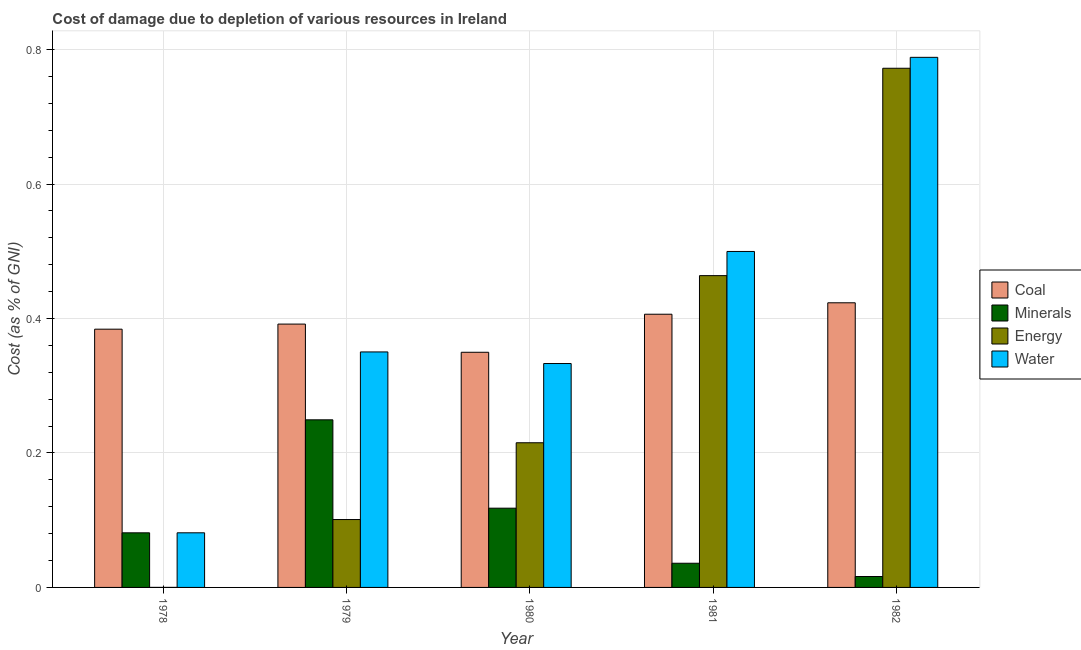How many different coloured bars are there?
Your response must be concise. 4. Are the number of bars per tick equal to the number of legend labels?
Keep it short and to the point. Yes. Are the number of bars on each tick of the X-axis equal?
Offer a terse response. Yes. How many bars are there on the 1st tick from the left?
Ensure brevity in your answer.  4. How many bars are there on the 2nd tick from the right?
Offer a terse response. 4. What is the label of the 4th group of bars from the left?
Provide a succinct answer. 1981. What is the cost of damage due to depletion of coal in 1982?
Your answer should be very brief. 0.42. Across all years, what is the maximum cost of damage due to depletion of water?
Make the answer very short. 0.79. Across all years, what is the minimum cost of damage due to depletion of coal?
Your response must be concise. 0.35. In which year was the cost of damage due to depletion of water maximum?
Provide a succinct answer. 1982. In which year was the cost of damage due to depletion of energy minimum?
Your answer should be compact. 1978. What is the total cost of damage due to depletion of water in the graph?
Offer a terse response. 2.05. What is the difference between the cost of damage due to depletion of coal in 1981 and that in 1982?
Ensure brevity in your answer.  -0.02. What is the difference between the cost of damage due to depletion of minerals in 1982 and the cost of damage due to depletion of coal in 1980?
Your answer should be very brief. -0.1. What is the average cost of damage due to depletion of minerals per year?
Make the answer very short. 0.1. In the year 1981, what is the difference between the cost of damage due to depletion of minerals and cost of damage due to depletion of coal?
Offer a very short reply. 0. In how many years, is the cost of damage due to depletion of minerals greater than 0.32 %?
Make the answer very short. 0. What is the ratio of the cost of damage due to depletion of energy in 1980 to that in 1981?
Offer a terse response. 0.46. What is the difference between the highest and the second highest cost of damage due to depletion of minerals?
Your answer should be very brief. 0.13. What is the difference between the highest and the lowest cost of damage due to depletion of coal?
Offer a terse response. 0.07. In how many years, is the cost of damage due to depletion of minerals greater than the average cost of damage due to depletion of minerals taken over all years?
Provide a succinct answer. 2. What does the 2nd bar from the left in 1979 represents?
Make the answer very short. Minerals. What does the 1st bar from the right in 1981 represents?
Provide a succinct answer. Water. Are all the bars in the graph horizontal?
Your answer should be very brief. No. What is the difference between two consecutive major ticks on the Y-axis?
Offer a terse response. 0.2. Where does the legend appear in the graph?
Keep it short and to the point. Center right. How many legend labels are there?
Provide a succinct answer. 4. What is the title of the graph?
Provide a short and direct response. Cost of damage due to depletion of various resources in Ireland . What is the label or title of the X-axis?
Your answer should be very brief. Year. What is the label or title of the Y-axis?
Your response must be concise. Cost (as % of GNI). What is the Cost (as % of GNI) in Coal in 1978?
Your answer should be very brief. 0.38. What is the Cost (as % of GNI) of Minerals in 1978?
Your answer should be very brief. 0.08. What is the Cost (as % of GNI) of Energy in 1978?
Offer a terse response. 3.38604174226955e-5. What is the Cost (as % of GNI) in Water in 1978?
Provide a short and direct response. 0.08. What is the Cost (as % of GNI) in Coal in 1979?
Make the answer very short. 0.39. What is the Cost (as % of GNI) in Minerals in 1979?
Keep it short and to the point. 0.25. What is the Cost (as % of GNI) of Energy in 1979?
Give a very brief answer. 0.1. What is the Cost (as % of GNI) of Water in 1979?
Provide a short and direct response. 0.35. What is the Cost (as % of GNI) in Coal in 1980?
Provide a short and direct response. 0.35. What is the Cost (as % of GNI) of Minerals in 1980?
Give a very brief answer. 0.12. What is the Cost (as % of GNI) in Energy in 1980?
Offer a very short reply. 0.22. What is the Cost (as % of GNI) in Water in 1980?
Offer a very short reply. 0.33. What is the Cost (as % of GNI) in Coal in 1981?
Your response must be concise. 0.41. What is the Cost (as % of GNI) in Minerals in 1981?
Ensure brevity in your answer.  0.04. What is the Cost (as % of GNI) in Energy in 1981?
Your answer should be very brief. 0.46. What is the Cost (as % of GNI) in Water in 1981?
Offer a very short reply. 0.5. What is the Cost (as % of GNI) in Coal in 1982?
Provide a short and direct response. 0.42. What is the Cost (as % of GNI) of Minerals in 1982?
Your response must be concise. 0.02. What is the Cost (as % of GNI) in Energy in 1982?
Your response must be concise. 0.77. What is the Cost (as % of GNI) in Water in 1982?
Your response must be concise. 0.79. Across all years, what is the maximum Cost (as % of GNI) of Coal?
Your response must be concise. 0.42. Across all years, what is the maximum Cost (as % of GNI) in Minerals?
Keep it short and to the point. 0.25. Across all years, what is the maximum Cost (as % of GNI) in Energy?
Provide a succinct answer. 0.77. Across all years, what is the maximum Cost (as % of GNI) of Water?
Your response must be concise. 0.79. Across all years, what is the minimum Cost (as % of GNI) in Coal?
Make the answer very short. 0.35. Across all years, what is the minimum Cost (as % of GNI) of Minerals?
Ensure brevity in your answer.  0.02. Across all years, what is the minimum Cost (as % of GNI) in Energy?
Provide a succinct answer. 3.38604174226955e-5. Across all years, what is the minimum Cost (as % of GNI) of Water?
Keep it short and to the point. 0.08. What is the total Cost (as % of GNI) in Coal in the graph?
Make the answer very short. 1.96. What is the total Cost (as % of GNI) in Minerals in the graph?
Provide a short and direct response. 0.5. What is the total Cost (as % of GNI) in Energy in the graph?
Keep it short and to the point. 1.55. What is the total Cost (as % of GNI) in Water in the graph?
Your answer should be very brief. 2.05. What is the difference between the Cost (as % of GNI) of Coal in 1978 and that in 1979?
Offer a very short reply. -0.01. What is the difference between the Cost (as % of GNI) of Minerals in 1978 and that in 1979?
Provide a succinct answer. -0.17. What is the difference between the Cost (as % of GNI) of Energy in 1978 and that in 1979?
Your answer should be very brief. -0.1. What is the difference between the Cost (as % of GNI) in Water in 1978 and that in 1979?
Your response must be concise. -0.27. What is the difference between the Cost (as % of GNI) in Coal in 1978 and that in 1980?
Your answer should be very brief. 0.03. What is the difference between the Cost (as % of GNI) in Minerals in 1978 and that in 1980?
Provide a succinct answer. -0.04. What is the difference between the Cost (as % of GNI) in Energy in 1978 and that in 1980?
Your answer should be very brief. -0.22. What is the difference between the Cost (as % of GNI) in Water in 1978 and that in 1980?
Provide a succinct answer. -0.25. What is the difference between the Cost (as % of GNI) of Coal in 1978 and that in 1981?
Your response must be concise. -0.02. What is the difference between the Cost (as % of GNI) in Minerals in 1978 and that in 1981?
Provide a succinct answer. 0.05. What is the difference between the Cost (as % of GNI) in Energy in 1978 and that in 1981?
Your response must be concise. -0.46. What is the difference between the Cost (as % of GNI) in Water in 1978 and that in 1981?
Your answer should be compact. -0.42. What is the difference between the Cost (as % of GNI) of Coal in 1978 and that in 1982?
Your response must be concise. -0.04. What is the difference between the Cost (as % of GNI) in Minerals in 1978 and that in 1982?
Your answer should be very brief. 0.07. What is the difference between the Cost (as % of GNI) of Energy in 1978 and that in 1982?
Provide a succinct answer. -0.77. What is the difference between the Cost (as % of GNI) in Water in 1978 and that in 1982?
Ensure brevity in your answer.  -0.71. What is the difference between the Cost (as % of GNI) of Coal in 1979 and that in 1980?
Give a very brief answer. 0.04. What is the difference between the Cost (as % of GNI) in Minerals in 1979 and that in 1980?
Make the answer very short. 0.13. What is the difference between the Cost (as % of GNI) of Energy in 1979 and that in 1980?
Ensure brevity in your answer.  -0.11. What is the difference between the Cost (as % of GNI) of Water in 1979 and that in 1980?
Your response must be concise. 0.02. What is the difference between the Cost (as % of GNI) of Coal in 1979 and that in 1981?
Your answer should be compact. -0.01. What is the difference between the Cost (as % of GNI) in Minerals in 1979 and that in 1981?
Offer a terse response. 0.21. What is the difference between the Cost (as % of GNI) of Energy in 1979 and that in 1981?
Provide a succinct answer. -0.36. What is the difference between the Cost (as % of GNI) in Water in 1979 and that in 1981?
Provide a succinct answer. -0.15. What is the difference between the Cost (as % of GNI) in Coal in 1979 and that in 1982?
Your answer should be compact. -0.03. What is the difference between the Cost (as % of GNI) of Minerals in 1979 and that in 1982?
Your answer should be very brief. 0.23. What is the difference between the Cost (as % of GNI) in Energy in 1979 and that in 1982?
Make the answer very short. -0.67. What is the difference between the Cost (as % of GNI) in Water in 1979 and that in 1982?
Make the answer very short. -0.44. What is the difference between the Cost (as % of GNI) in Coal in 1980 and that in 1981?
Your answer should be compact. -0.06. What is the difference between the Cost (as % of GNI) in Minerals in 1980 and that in 1981?
Ensure brevity in your answer.  0.08. What is the difference between the Cost (as % of GNI) in Energy in 1980 and that in 1981?
Offer a very short reply. -0.25. What is the difference between the Cost (as % of GNI) of Coal in 1980 and that in 1982?
Offer a very short reply. -0.07. What is the difference between the Cost (as % of GNI) in Minerals in 1980 and that in 1982?
Keep it short and to the point. 0.1. What is the difference between the Cost (as % of GNI) in Energy in 1980 and that in 1982?
Ensure brevity in your answer.  -0.56. What is the difference between the Cost (as % of GNI) of Water in 1980 and that in 1982?
Your response must be concise. -0.46. What is the difference between the Cost (as % of GNI) of Coal in 1981 and that in 1982?
Keep it short and to the point. -0.02. What is the difference between the Cost (as % of GNI) in Minerals in 1981 and that in 1982?
Your answer should be compact. 0.02. What is the difference between the Cost (as % of GNI) of Energy in 1981 and that in 1982?
Give a very brief answer. -0.31. What is the difference between the Cost (as % of GNI) of Water in 1981 and that in 1982?
Your answer should be very brief. -0.29. What is the difference between the Cost (as % of GNI) in Coal in 1978 and the Cost (as % of GNI) in Minerals in 1979?
Your response must be concise. 0.13. What is the difference between the Cost (as % of GNI) in Coal in 1978 and the Cost (as % of GNI) in Energy in 1979?
Your answer should be compact. 0.28. What is the difference between the Cost (as % of GNI) of Coal in 1978 and the Cost (as % of GNI) of Water in 1979?
Offer a terse response. 0.03. What is the difference between the Cost (as % of GNI) of Minerals in 1978 and the Cost (as % of GNI) of Energy in 1979?
Provide a succinct answer. -0.02. What is the difference between the Cost (as % of GNI) in Minerals in 1978 and the Cost (as % of GNI) in Water in 1979?
Make the answer very short. -0.27. What is the difference between the Cost (as % of GNI) of Energy in 1978 and the Cost (as % of GNI) of Water in 1979?
Provide a short and direct response. -0.35. What is the difference between the Cost (as % of GNI) of Coal in 1978 and the Cost (as % of GNI) of Minerals in 1980?
Provide a succinct answer. 0.27. What is the difference between the Cost (as % of GNI) in Coal in 1978 and the Cost (as % of GNI) in Energy in 1980?
Make the answer very short. 0.17. What is the difference between the Cost (as % of GNI) in Coal in 1978 and the Cost (as % of GNI) in Water in 1980?
Make the answer very short. 0.05. What is the difference between the Cost (as % of GNI) in Minerals in 1978 and the Cost (as % of GNI) in Energy in 1980?
Offer a terse response. -0.13. What is the difference between the Cost (as % of GNI) in Minerals in 1978 and the Cost (as % of GNI) in Water in 1980?
Keep it short and to the point. -0.25. What is the difference between the Cost (as % of GNI) of Energy in 1978 and the Cost (as % of GNI) of Water in 1980?
Your response must be concise. -0.33. What is the difference between the Cost (as % of GNI) of Coal in 1978 and the Cost (as % of GNI) of Minerals in 1981?
Offer a terse response. 0.35. What is the difference between the Cost (as % of GNI) in Coal in 1978 and the Cost (as % of GNI) in Energy in 1981?
Your answer should be very brief. -0.08. What is the difference between the Cost (as % of GNI) of Coal in 1978 and the Cost (as % of GNI) of Water in 1981?
Provide a short and direct response. -0.12. What is the difference between the Cost (as % of GNI) of Minerals in 1978 and the Cost (as % of GNI) of Energy in 1981?
Your answer should be very brief. -0.38. What is the difference between the Cost (as % of GNI) in Minerals in 1978 and the Cost (as % of GNI) in Water in 1981?
Your answer should be compact. -0.42. What is the difference between the Cost (as % of GNI) of Energy in 1978 and the Cost (as % of GNI) of Water in 1981?
Ensure brevity in your answer.  -0.5. What is the difference between the Cost (as % of GNI) of Coal in 1978 and the Cost (as % of GNI) of Minerals in 1982?
Keep it short and to the point. 0.37. What is the difference between the Cost (as % of GNI) in Coal in 1978 and the Cost (as % of GNI) in Energy in 1982?
Offer a very short reply. -0.39. What is the difference between the Cost (as % of GNI) of Coal in 1978 and the Cost (as % of GNI) of Water in 1982?
Make the answer very short. -0.4. What is the difference between the Cost (as % of GNI) of Minerals in 1978 and the Cost (as % of GNI) of Energy in 1982?
Provide a short and direct response. -0.69. What is the difference between the Cost (as % of GNI) in Minerals in 1978 and the Cost (as % of GNI) in Water in 1982?
Give a very brief answer. -0.71. What is the difference between the Cost (as % of GNI) of Energy in 1978 and the Cost (as % of GNI) of Water in 1982?
Give a very brief answer. -0.79. What is the difference between the Cost (as % of GNI) in Coal in 1979 and the Cost (as % of GNI) in Minerals in 1980?
Your answer should be compact. 0.27. What is the difference between the Cost (as % of GNI) in Coal in 1979 and the Cost (as % of GNI) in Energy in 1980?
Provide a short and direct response. 0.18. What is the difference between the Cost (as % of GNI) of Coal in 1979 and the Cost (as % of GNI) of Water in 1980?
Provide a succinct answer. 0.06. What is the difference between the Cost (as % of GNI) of Minerals in 1979 and the Cost (as % of GNI) of Energy in 1980?
Your answer should be compact. 0.03. What is the difference between the Cost (as % of GNI) of Minerals in 1979 and the Cost (as % of GNI) of Water in 1980?
Your answer should be very brief. -0.08. What is the difference between the Cost (as % of GNI) in Energy in 1979 and the Cost (as % of GNI) in Water in 1980?
Give a very brief answer. -0.23. What is the difference between the Cost (as % of GNI) of Coal in 1979 and the Cost (as % of GNI) of Minerals in 1981?
Provide a short and direct response. 0.36. What is the difference between the Cost (as % of GNI) in Coal in 1979 and the Cost (as % of GNI) in Energy in 1981?
Keep it short and to the point. -0.07. What is the difference between the Cost (as % of GNI) of Coal in 1979 and the Cost (as % of GNI) of Water in 1981?
Make the answer very short. -0.11. What is the difference between the Cost (as % of GNI) of Minerals in 1979 and the Cost (as % of GNI) of Energy in 1981?
Offer a terse response. -0.21. What is the difference between the Cost (as % of GNI) in Minerals in 1979 and the Cost (as % of GNI) in Water in 1981?
Make the answer very short. -0.25. What is the difference between the Cost (as % of GNI) in Energy in 1979 and the Cost (as % of GNI) in Water in 1981?
Offer a terse response. -0.4. What is the difference between the Cost (as % of GNI) of Coal in 1979 and the Cost (as % of GNI) of Minerals in 1982?
Keep it short and to the point. 0.38. What is the difference between the Cost (as % of GNI) in Coal in 1979 and the Cost (as % of GNI) in Energy in 1982?
Make the answer very short. -0.38. What is the difference between the Cost (as % of GNI) of Coal in 1979 and the Cost (as % of GNI) of Water in 1982?
Your answer should be very brief. -0.4. What is the difference between the Cost (as % of GNI) of Minerals in 1979 and the Cost (as % of GNI) of Energy in 1982?
Offer a terse response. -0.52. What is the difference between the Cost (as % of GNI) in Minerals in 1979 and the Cost (as % of GNI) in Water in 1982?
Offer a very short reply. -0.54. What is the difference between the Cost (as % of GNI) in Energy in 1979 and the Cost (as % of GNI) in Water in 1982?
Your response must be concise. -0.69. What is the difference between the Cost (as % of GNI) in Coal in 1980 and the Cost (as % of GNI) in Minerals in 1981?
Give a very brief answer. 0.31. What is the difference between the Cost (as % of GNI) of Coal in 1980 and the Cost (as % of GNI) of Energy in 1981?
Keep it short and to the point. -0.11. What is the difference between the Cost (as % of GNI) of Minerals in 1980 and the Cost (as % of GNI) of Energy in 1981?
Provide a short and direct response. -0.35. What is the difference between the Cost (as % of GNI) of Minerals in 1980 and the Cost (as % of GNI) of Water in 1981?
Give a very brief answer. -0.38. What is the difference between the Cost (as % of GNI) in Energy in 1980 and the Cost (as % of GNI) in Water in 1981?
Give a very brief answer. -0.28. What is the difference between the Cost (as % of GNI) in Coal in 1980 and the Cost (as % of GNI) in Minerals in 1982?
Provide a short and direct response. 0.33. What is the difference between the Cost (as % of GNI) in Coal in 1980 and the Cost (as % of GNI) in Energy in 1982?
Make the answer very short. -0.42. What is the difference between the Cost (as % of GNI) of Coal in 1980 and the Cost (as % of GNI) of Water in 1982?
Your response must be concise. -0.44. What is the difference between the Cost (as % of GNI) of Minerals in 1980 and the Cost (as % of GNI) of Energy in 1982?
Your answer should be compact. -0.65. What is the difference between the Cost (as % of GNI) in Minerals in 1980 and the Cost (as % of GNI) in Water in 1982?
Provide a short and direct response. -0.67. What is the difference between the Cost (as % of GNI) in Energy in 1980 and the Cost (as % of GNI) in Water in 1982?
Offer a terse response. -0.57. What is the difference between the Cost (as % of GNI) in Coal in 1981 and the Cost (as % of GNI) in Minerals in 1982?
Your answer should be very brief. 0.39. What is the difference between the Cost (as % of GNI) of Coal in 1981 and the Cost (as % of GNI) of Energy in 1982?
Make the answer very short. -0.37. What is the difference between the Cost (as % of GNI) of Coal in 1981 and the Cost (as % of GNI) of Water in 1982?
Keep it short and to the point. -0.38. What is the difference between the Cost (as % of GNI) of Minerals in 1981 and the Cost (as % of GNI) of Energy in 1982?
Give a very brief answer. -0.74. What is the difference between the Cost (as % of GNI) of Minerals in 1981 and the Cost (as % of GNI) of Water in 1982?
Offer a very short reply. -0.75. What is the difference between the Cost (as % of GNI) of Energy in 1981 and the Cost (as % of GNI) of Water in 1982?
Your answer should be very brief. -0.32. What is the average Cost (as % of GNI) in Coal per year?
Offer a terse response. 0.39. What is the average Cost (as % of GNI) in Minerals per year?
Offer a terse response. 0.1. What is the average Cost (as % of GNI) in Energy per year?
Ensure brevity in your answer.  0.31. What is the average Cost (as % of GNI) in Water per year?
Provide a succinct answer. 0.41. In the year 1978, what is the difference between the Cost (as % of GNI) in Coal and Cost (as % of GNI) in Minerals?
Offer a terse response. 0.3. In the year 1978, what is the difference between the Cost (as % of GNI) in Coal and Cost (as % of GNI) in Energy?
Your answer should be compact. 0.38. In the year 1978, what is the difference between the Cost (as % of GNI) of Coal and Cost (as % of GNI) of Water?
Offer a very short reply. 0.3. In the year 1978, what is the difference between the Cost (as % of GNI) in Minerals and Cost (as % of GNI) in Energy?
Give a very brief answer. 0.08. In the year 1978, what is the difference between the Cost (as % of GNI) of Minerals and Cost (as % of GNI) of Water?
Your response must be concise. -0. In the year 1978, what is the difference between the Cost (as % of GNI) in Energy and Cost (as % of GNI) in Water?
Give a very brief answer. -0.08. In the year 1979, what is the difference between the Cost (as % of GNI) in Coal and Cost (as % of GNI) in Minerals?
Ensure brevity in your answer.  0.14. In the year 1979, what is the difference between the Cost (as % of GNI) in Coal and Cost (as % of GNI) in Energy?
Make the answer very short. 0.29. In the year 1979, what is the difference between the Cost (as % of GNI) of Coal and Cost (as % of GNI) of Water?
Offer a very short reply. 0.04. In the year 1979, what is the difference between the Cost (as % of GNI) of Minerals and Cost (as % of GNI) of Energy?
Provide a short and direct response. 0.15. In the year 1979, what is the difference between the Cost (as % of GNI) in Minerals and Cost (as % of GNI) in Water?
Offer a very short reply. -0.1. In the year 1979, what is the difference between the Cost (as % of GNI) of Energy and Cost (as % of GNI) of Water?
Your response must be concise. -0.25. In the year 1980, what is the difference between the Cost (as % of GNI) of Coal and Cost (as % of GNI) of Minerals?
Your response must be concise. 0.23. In the year 1980, what is the difference between the Cost (as % of GNI) of Coal and Cost (as % of GNI) of Energy?
Ensure brevity in your answer.  0.13. In the year 1980, what is the difference between the Cost (as % of GNI) in Coal and Cost (as % of GNI) in Water?
Your answer should be compact. 0.02. In the year 1980, what is the difference between the Cost (as % of GNI) of Minerals and Cost (as % of GNI) of Energy?
Provide a short and direct response. -0.1. In the year 1980, what is the difference between the Cost (as % of GNI) of Minerals and Cost (as % of GNI) of Water?
Your answer should be compact. -0.22. In the year 1980, what is the difference between the Cost (as % of GNI) of Energy and Cost (as % of GNI) of Water?
Provide a succinct answer. -0.12. In the year 1981, what is the difference between the Cost (as % of GNI) of Coal and Cost (as % of GNI) of Minerals?
Keep it short and to the point. 0.37. In the year 1981, what is the difference between the Cost (as % of GNI) in Coal and Cost (as % of GNI) in Energy?
Your response must be concise. -0.06. In the year 1981, what is the difference between the Cost (as % of GNI) in Coal and Cost (as % of GNI) in Water?
Provide a succinct answer. -0.09. In the year 1981, what is the difference between the Cost (as % of GNI) of Minerals and Cost (as % of GNI) of Energy?
Your answer should be compact. -0.43. In the year 1981, what is the difference between the Cost (as % of GNI) in Minerals and Cost (as % of GNI) in Water?
Make the answer very short. -0.46. In the year 1981, what is the difference between the Cost (as % of GNI) in Energy and Cost (as % of GNI) in Water?
Provide a succinct answer. -0.04. In the year 1982, what is the difference between the Cost (as % of GNI) in Coal and Cost (as % of GNI) in Minerals?
Give a very brief answer. 0.41. In the year 1982, what is the difference between the Cost (as % of GNI) in Coal and Cost (as % of GNI) in Energy?
Offer a terse response. -0.35. In the year 1982, what is the difference between the Cost (as % of GNI) in Coal and Cost (as % of GNI) in Water?
Provide a succinct answer. -0.37. In the year 1982, what is the difference between the Cost (as % of GNI) in Minerals and Cost (as % of GNI) in Energy?
Your answer should be very brief. -0.76. In the year 1982, what is the difference between the Cost (as % of GNI) of Minerals and Cost (as % of GNI) of Water?
Your response must be concise. -0.77. In the year 1982, what is the difference between the Cost (as % of GNI) of Energy and Cost (as % of GNI) of Water?
Your response must be concise. -0.02. What is the ratio of the Cost (as % of GNI) of Coal in 1978 to that in 1979?
Offer a very short reply. 0.98. What is the ratio of the Cost (as % of GNI) in Minerals in 1978 to that in 1979?
Make the answer very short. 0.33. What is the ratio of the Cost (as % of GNI) in Water in 1978 to that in 1979?
Your response must be concise. 0.23. What is the ratio of the Cost (as % of GNI) in Coal in 1978 to that in 1980?
Ensure brevity in your answer.  1.1. What is the ratio of the Cost (as % of GNI) of Minerals in 1978 to that in 1980?
Your answer should be very brief. 0.69. What is the ratio of the Cost (as % of GNI) in Energy in 1978 to that in 1980?
Provide a succinct answer. 0. What is the ratio of the Cost (as % of GNI) of Water in 1978 to that in 1980?
Offer a very short reply. 0.24. What is the ratio of the Cost (as % of GNI) in Coal in 1978 to that in 1981?
Offer a very short reply. 0.95. What is the ratio of the Cost (as % of GNI) in Minerals in 1978 to that in 1981?
Provide a succinct answer. 2.26. What is the ratio of the Cost (as % of GNI) in Energy in 1978 to that in 1981?
Keep it short and to the point. 0. What is the ratio of the Cost (as % of GNI) in Water in 1978 to that in 1981?
Give a very brief answer. 0.16. What is the ratio of the Cost (as % of GNI) in Coal in 1978 to that in 1982?
Your response must be concise. 0.91. What is the ratio of the Cost (as % of GNI) of Minerals in 1978 to that in 1982?
Provide a short and direct response. 5. What is the ratio of the Cost (as % of GNI) of Water in 1978 to that in 1982?
Offer a very short reply. 0.1. What is the ratio of the Cost (as % of GNI) in Coal in 1979 to that in 1980?
Offer a terse response. 1.12. What is the ratio of the Cost (as % of GNI) in Minerals in 1979 to that in 1980?
Provide a succinct answer. 2.12. What is the ratio of the Cost (as % of GNI) of Energy in 1979 to that in 1980?
Your response must be concise. 0.47. What is the ratio of the Cost (as % of GNI) in Water in 1979 to that in 1980?
Your answer should be compact. 1.05. What is the ratio of the Cost (as % of GNI) in Coal in 1979 to that in 1981?
Offer a very short reply. 0.96. What is the ratio of the Cost (as % of GNI) in Minerals in 1979 to that in 1981?
Offer a very short reply. 6.93. What is the ratio of the Cost (as % of GNI) of Energy in 1979 to that in 1981?
Give a very brief answer. 0.22. What is the ratio of the Cost (as % of GNI) in Water in 1979 to that in 1981?
Your response must be concise. 0.7. What is the ratio of the Cost (as % of GNI) of Coal in 1979 to that in 1982?
Your response must be concise. 0.93. What is the ratio of the Cost (as % of GNI) in Minerals in 1979 to that in 1982?
Offer a terse response. 15.34. What is the ratio of the Cost (as % of GNI) in Energy in 1979 to that in 1982?
Your answer should be very brief. 0.13. What is the ratio of the Cost (as % of GNI) in Water in 1979 to that in 1982?
Ensure brevity in your answer.  0.44. What is the ratio of the Cost (as % of GNI) of Coal in 1980 to that in 1981?
Ensure brevity in your answer.  0.86. What is the ratio of the Cost (as % of GNI) of Minerals in 1980 to that in 1981?
Provide a succinct answer. 3.28. What is the ratio of the Cost (as % of GNI) in Energy in 1980 to that in 1981?
Ensure brevity in your answer.  0.46. What is the ratio of the Cost (as % of GNI) of Water in 1980 to that in 1981?
Make the answer very short. 0.67. What is the ratio of the Cost (as % of GNI) in Coal in 1980 to that in 1982?
Offer a terse response. 0.83. What is the ratio of the Cost (as % of GNI) of Minerals in 1980 to that in 1982?
Give a very brief answer. 7.25. What is the ratio of the Cost (as % of GNI) of Energy in 1980 to that in 1982?
Your answer should be very brief. 0.28. What is the ratio of the Cost (as % of GNI) in Water in 1980 to that in 1982?
Your response must be concise. 0.42. What is the ratio of the Cost (as % of GNI) of Coal in 1981 to that in 1982?
Provide a succinct answer. 0.96. What is the ratio of the Cost (as % of GNI) of Minerals in 1981 to that in 1982?
Keep it short and to the point. 2.21. What is the ratio of the Cost (as % of GNI) in Energy in 1981 to that in 1982?
Your answer should be very brief. 0.6. What is the ratio of the Cost (as % of GNI) in Water in 1981 to that in 1982?
Your answer should be compact. 0.63. What is the difference between the highest and the second highest Cost (as % of GNI) of Coal?
Keep it short and to the point. 0.02. What is the difference between the highest and the second highest Cost (as % of GNI) of Minerals?
Your answer should be compact. 0.13. What is the difference between the highest and the second highest Cost (as % of GNI) of Energy?
Your response must be concise. 0.31. What is the difference between the highest and the second highest Cost (as % of GNI) in Water?
Give a very brief answer. 0.29. What is the difference between the highest and the lowest Cost (as % of GNI) of Coal?
Offer a terse response. 0.07. What is the difference between the highest and the lowest Cost (as % of GNI) of Minerals?
Make the answer very short. 0.23. What is the difference between the highest and the lowest Cost (as % of GNI) of Energy?
Make the answer very short. 0.77. What is the difference between the highest and the lowest Cost (as % of GNI) of Water?
Offer a terse response. 0.71. 